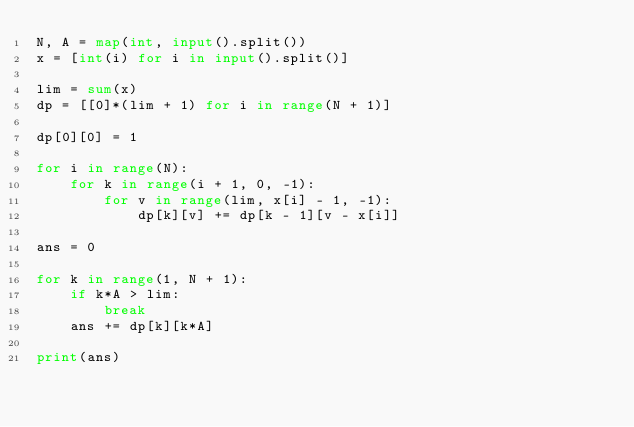<code> <loc_0><loc_0><loc_500><loc_500><_Python_>N, A = map(int, input().split())
x = [int(i) for i in input().split()]
 
lim = sum(x)
dp = [[0]*(lim + 1) for i in range(N + 1)]
 
dp[0][0] = 1
 
for i in range(N):
    for k in range(i + 1, 0, -1):
        for v in range(lim, x[i] - 1, -1):
            dp[k][v] += dp[k - 1][v - x[i]]
 
ans = 0

for k in range(1, N + 1):
    if k*A > lim:
        break
    ans += dp[k][k*A]

print(ans)</code> 